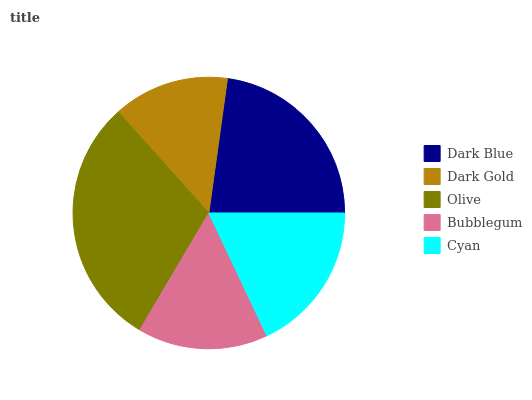Is Dark Gold the minimum?
Answer yes or no. Yes. Is Olive the maximum?
Answer yes or no. Yes. Is Olive the minimum?
Answer yes or no. No. Is Dark Gold the maximum?
Answer yes or no. No. Is Olive greater than Dark Gold?
Answer yes or no. Yes. Is Dark Gold less than Olive?
Answer yes or no. Yes. Is Dark Gold greater than Olive?
Answer yes or no. No. Is Olive less than Dark Gold?
Answer yes or no. No. Is Cyan the high median?
Answer yes or no. Yes. Is Cyan the low median?
Answer yes or no. Yes. Is Bubblegum the high median?
Answer yes or no. No. Is Bubblegum the low median?
Answer yes or no. No. 